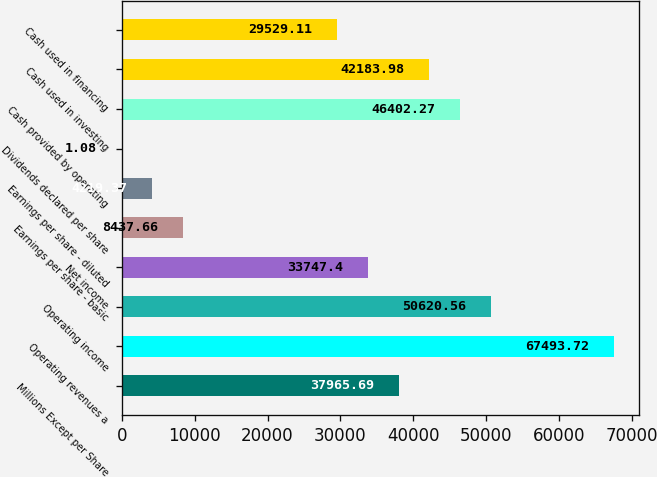Convert chart to OTSL. <chart><loc_0><loc_0><loc_500><loc_500><bar_chart><fcel>Millions Except per Share<fcel>Operating revenues a<fcel>Operating income<fcel>Net income<fcel>Earnings per share - basic<fcel>Earnings per share - diluted<fcel>Dividends declared per share<fcel>Cash provided by operating<fcel>Cash used in investing<fcel>Cash used in financing<nl><fcel>37965.7<fcel>67493.7<fcel>50620.6<fcel>33747.4<fcel>8437.66<fcel>4219.37<fcel>1.08<fcel>46402.3<fcel>42184<fcel>29529.1<nl></chart> 